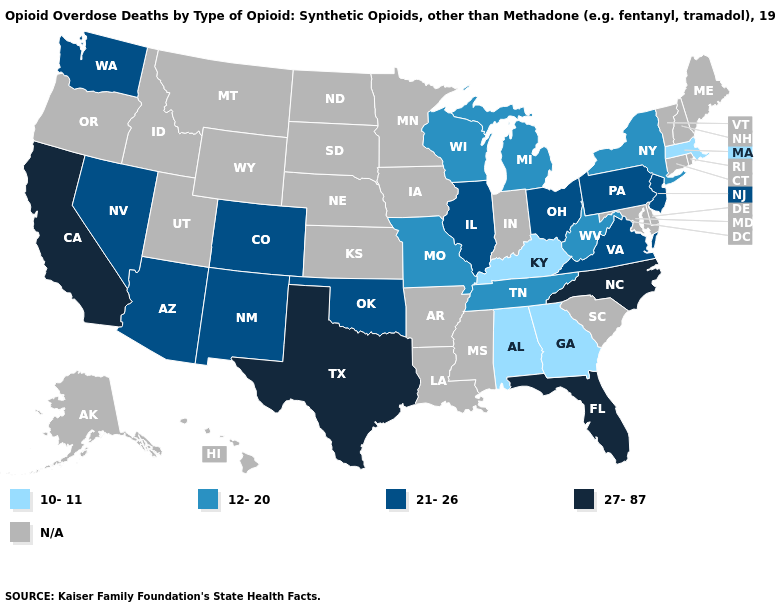Name the states that have a value in the range 27-87?
Be succinct. California, Florida, North Carolina, Texas. Among the states that border Mississippi , which have the lowest value?
Answer briefly. Alabama. Among the states that border Minnesota , which have the highest value?
Write a very short answer. Wisconsin. What is the highest value in the USA?
Be succinct. 27-87. Name the states that have a value in the range 10-11?
Answer briefly. Alabama, Georgia, Kentucky, Massachusetts. What is the lowest value in the USA?
Keep it brief. 10-11. Does the first symbol in the legend represent the smallest category?
Be succinct. Yes. Does Arizona have the lowest value in the West?
Keep it brief. Yes. Among the states that border New Jersey , which have the highest value?
Be succinct. Pennsylvania. What is the value of New Mexico?
Give a very brief answer. 21-26. Which states have the highest value in the USA?
Answer briefly. California, Florida, North Carolina, Texas. How many symbols are there in the legend?
Keep it brief. 5. What is the lowest value in the South?
Short answer required. 10-11. 